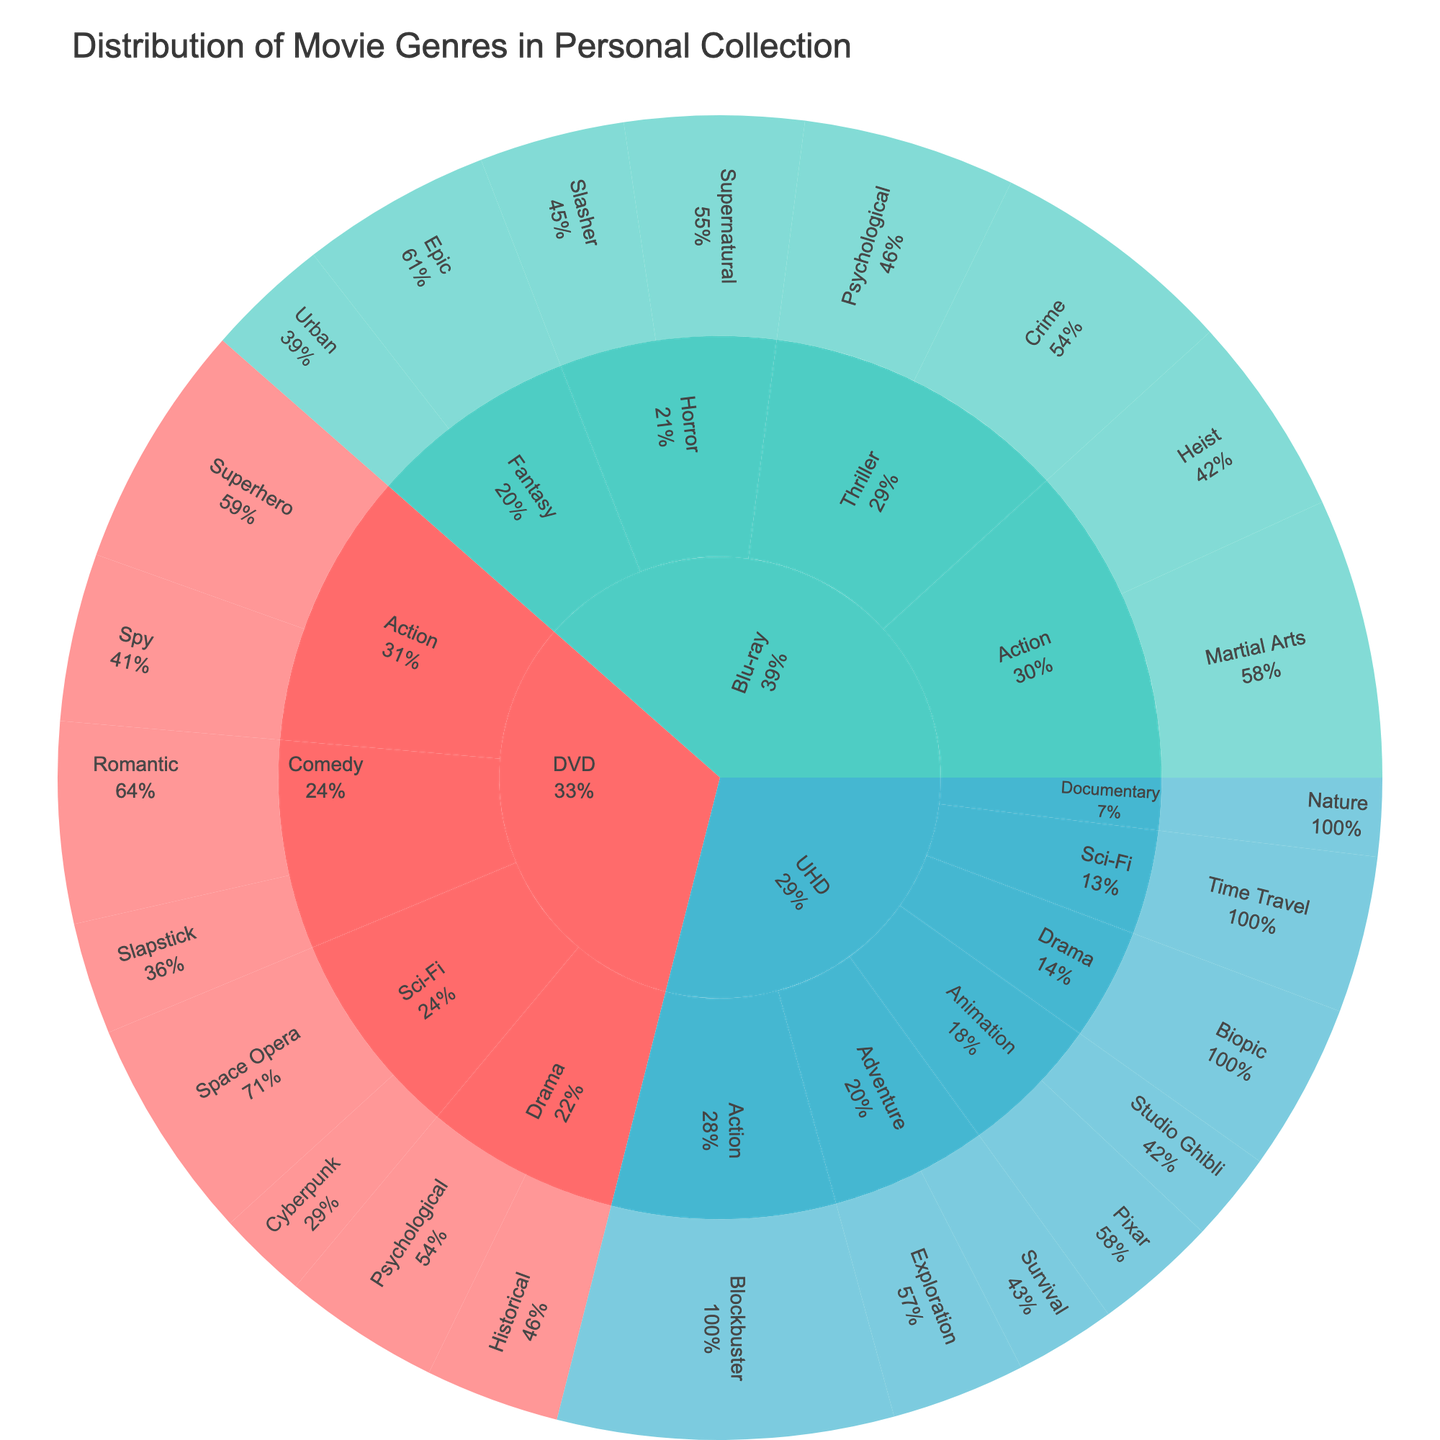What's the most common subgenre within the DVD format? Look at the DVD section and compare the counts of each subgenre. Superhero has 22 counts, higher than any other subgenre within DVD.
Answer: Superhero Which format has the highest total count of movies? Sum the counts for each format: DVD (119), Blu-ray (141), UHD (106). Blu-ray has the highest total count.
Answer: Blu-ray What percentage of the total Blu-ray collection is made up of the Action genre? Blu-ray Action genre totals (Martial Arts 25, Heist 18) equal 43. The total Blu-ray count is 141. (43/141) * 100 = 30.5%
Answer: 30.5% Between DVD and UHD, which format has a higher count for the Drama genre? Compare the counts for Drama under DVD (Historical 12, Psychological 14) and UHD (Biopic 15). DVD totals 26, UHD totals 15.
Answer: DVD How many more DVDs are there in the Comedy genre compared to Blu-ray movies in the Fantasy genre? DVD Comedy total (Romantic 18, Slapstick 10) is 28. Blu-ray Fantasy total (Epic 17, Urban 11) is 28. 28 - 28 = 0
Answer: 0 In which subgenre is there only a single-digit count in the UHD format? Examine UHD subgenres for any with counts less than 10. Documentary Nature has 7, Animation Studio Ghibli has 8, and Adventure Survival has 9.
Answer: Documentary Nature, Animation Studio Ghibli, and Adventure Survival Which format has more subgenres listed under the Action genre? The DVD format has Spy and Superhero, Blu-ray has Martial Arts and Heist, UHD has Blockbuster. Both DVD and Blu-ray have 2 subgenres, UHD has 1.
Answer: DVD and Blu-ray What's the total count of Sci-Fi movies across all formats? Sum counts from Sci-Fi under DVD (Space Opera 20, Cyberpunk 8) and UHD (Time Travel 14). 20 + 8 + 14 = 42
Answer: 42 Which format contributes the least to the Horror genre? Blu-ray is the only format with Horror, having Slasher 13 and Supernatural 16.
Answer: DVD and UHD contribute 0 Among Blu-ray Horror subgenres, which has a higher count? Compare Slasher (13) and Supernatural (16) directly. Supernatural has a higher count.
Answer: Supernatural 